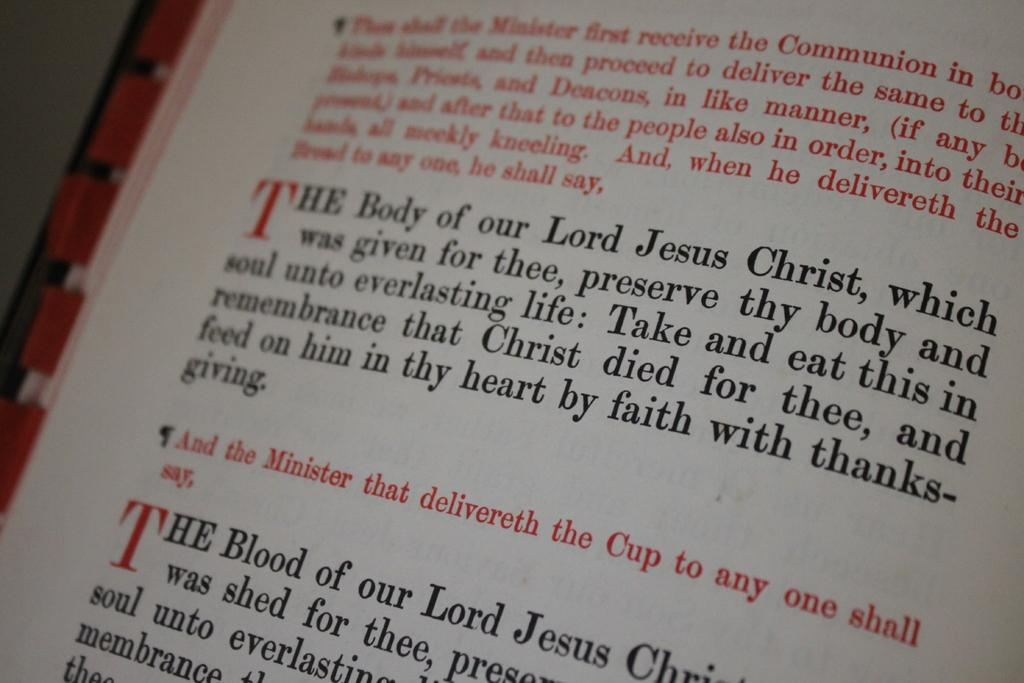<image>
Provide a brief description of the given image. Some of this scripture talks about the Lord Jesus Christ. 